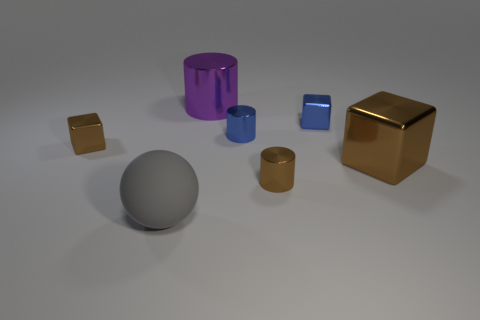Subtract all yellow balls. How many brown blocks are left? 2 Add 1 tiny red rubber cubes. How many objects exist? 8 Subtract all small shiny blocks. How many blocks are left? 1 Subtract 1 cubes. How many cubes are left? 2 Subtract all blocks. How many objects are left? 4 Add 1 tiny gray metallic things. How many tiny gray metallic things exist? 1 Subtract 1 purple cylinders. How many objects are left? 6 Subtract all cyan cylinders. Subtract all red spheres. How many cylinders are left? 3 Subtract all small brown things. Subtract all big brown rubber cylinders. How many objects are left? 5 Add 1 rubber spheres. How many rubber spheres are left? 2 